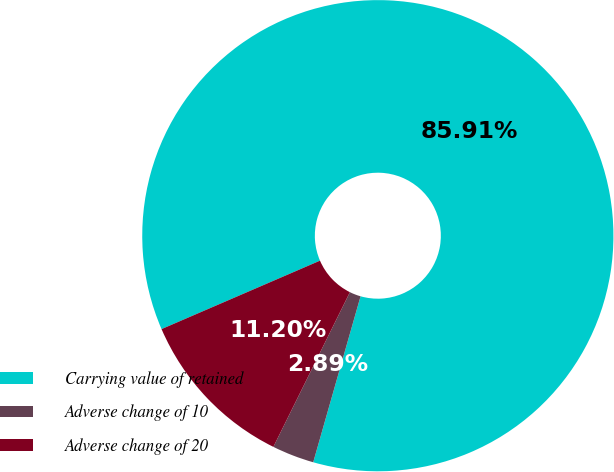Convert chart to OTSL. <chart><loc_0><loc_0><loc_500><loc_500><pie_chart><fcel>Carrying value of retained<fcel>Adverse change of 10<fcel>Adverse change of 20<nl><fcel>85.91%<fcel>2.89%<fcel>11.2%<nl></chart> 